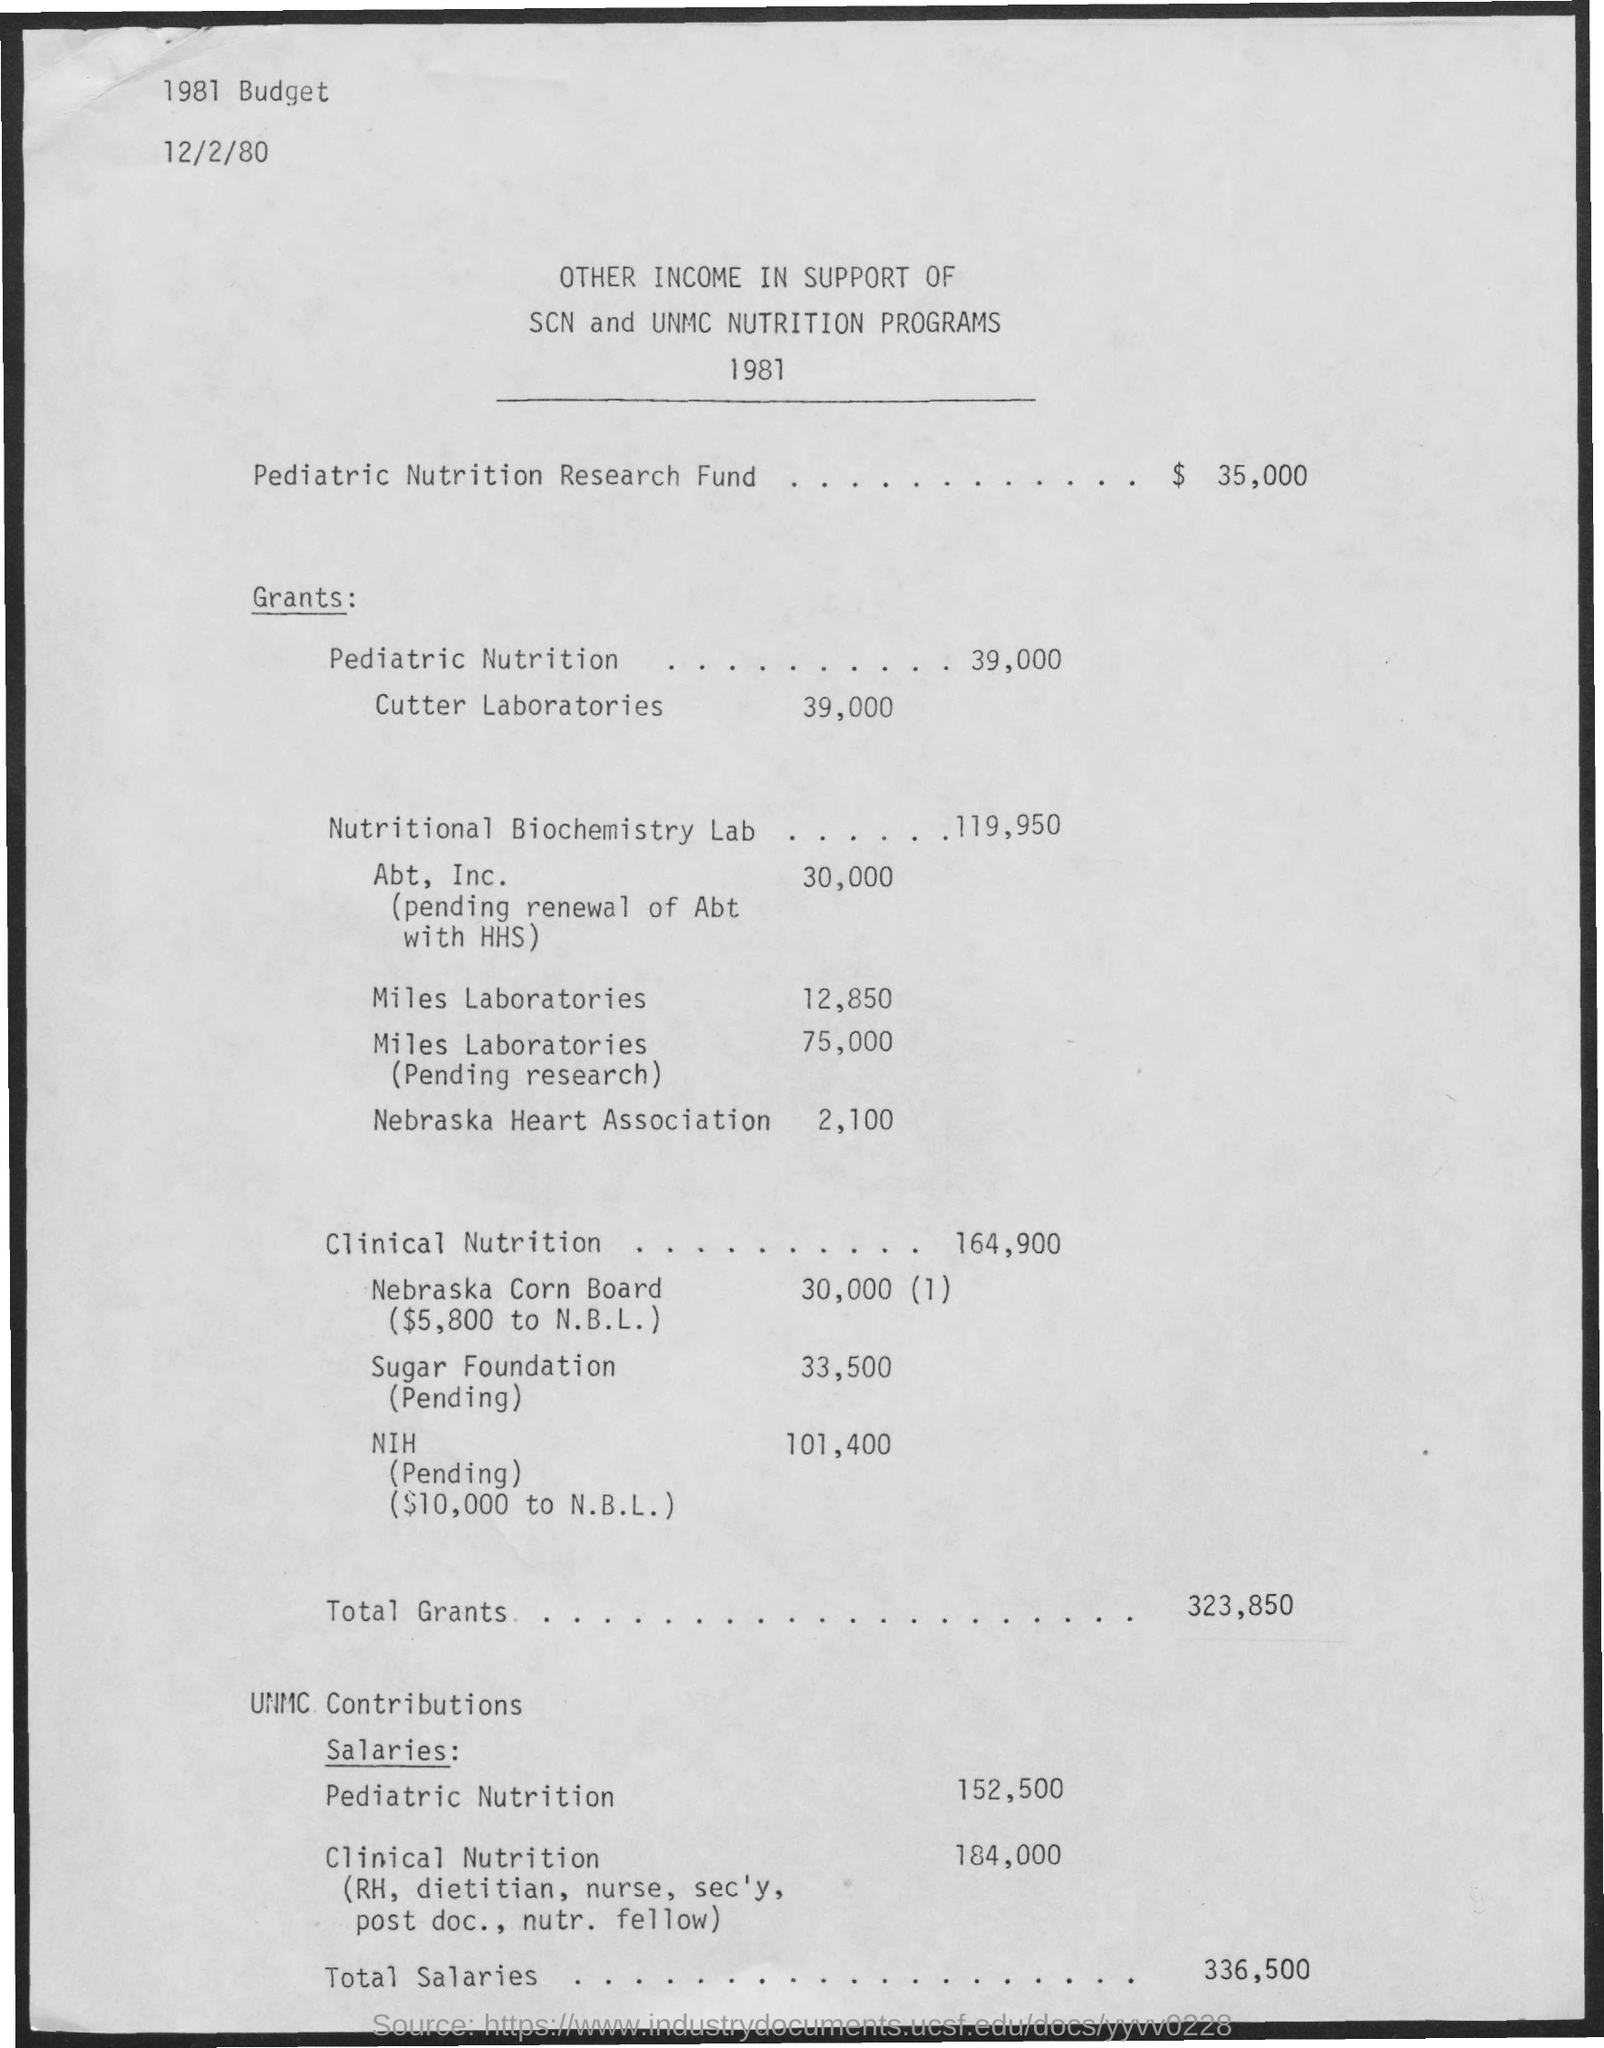Highlight a few significant elements in this photo. The Nebraska Heart Association has received a grant of $2,100. The amount of the grant for pediatric nutrition is 39,000. Miles Laboratories has received a grant of $12,850. Abt, Inc. has received grants of up to $30,000. Miles Laboratories is currently pending research grants totaling $75,000. 